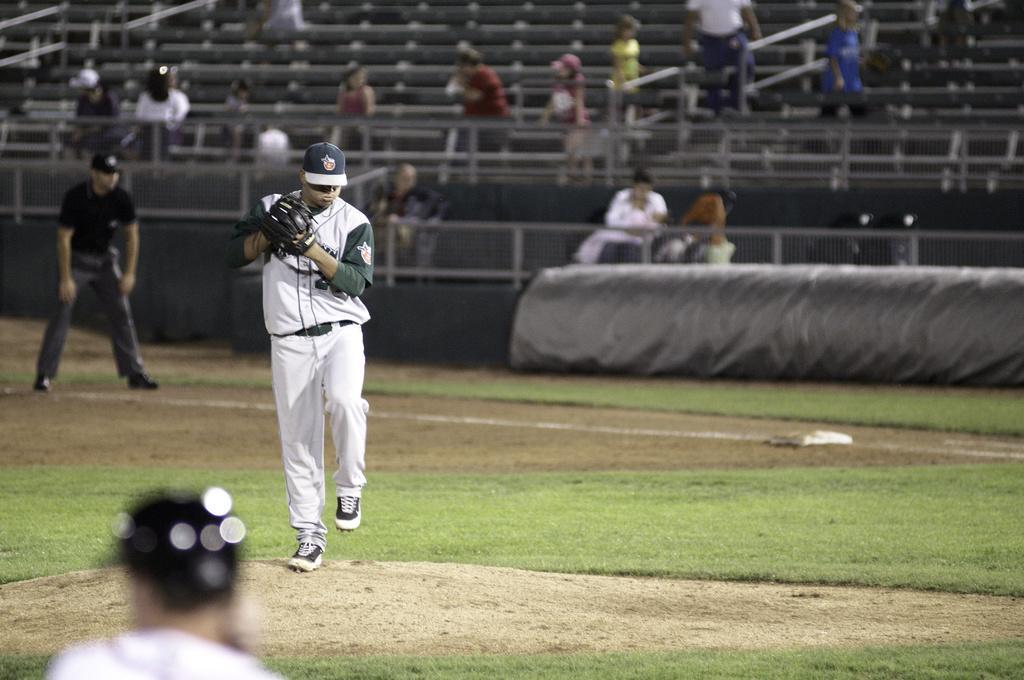Describe this image in one or two sentences. In this picture we can see three people and two men are standing on the ground. In the background we can see some people, railings and some objects. 